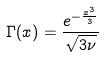<formula> <loc_0><loc_0><loc_500><loc_500>\Gamma ( x ) = \frac { e ^ { - \frac { x ^ { 3 } } { 3 } } } { \sqrt { 3 \nu } }</formula> 